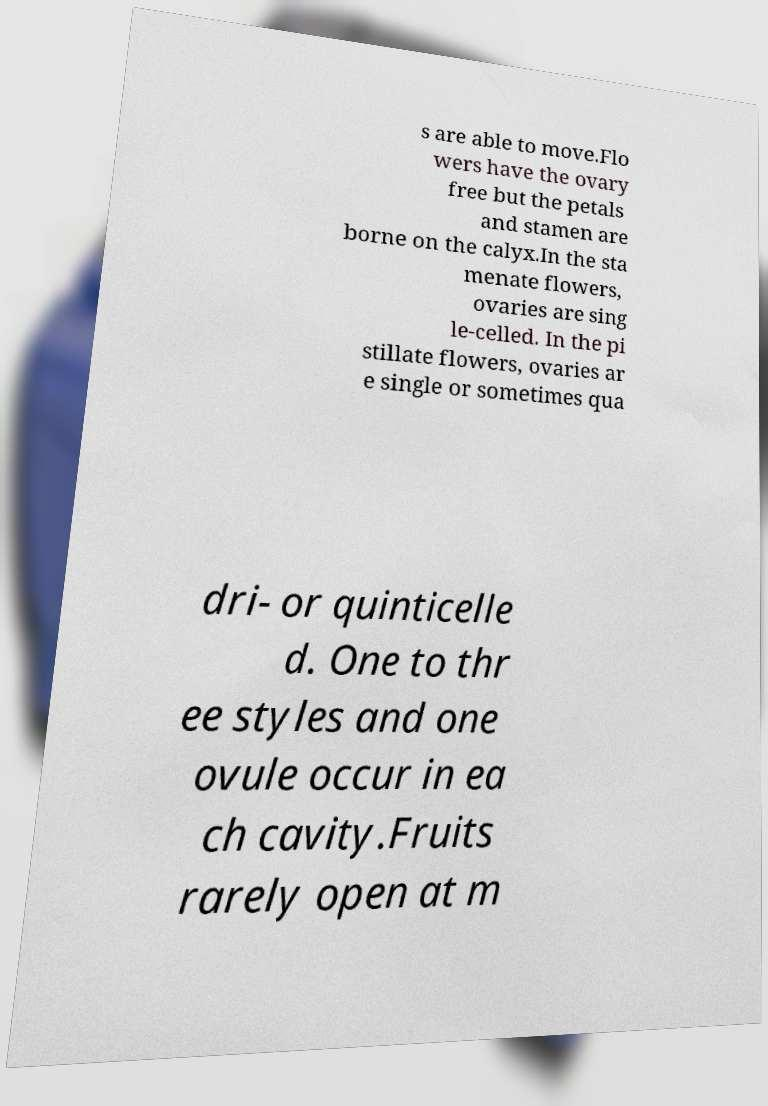Can you accurately transcribe the text from the provided image for me? s are able to move.Flo wers have the ovary free but the petals and stamen are borne on the calyx.In the sta menate flowers, ovaries are sing le-celled. In the pi stillate flowers, ovaries ar e single or sometimes qua dri- or quinticelle d. One to thr ee styles and one ovule occur in ea ch cavity.Fruits rarely open at m 